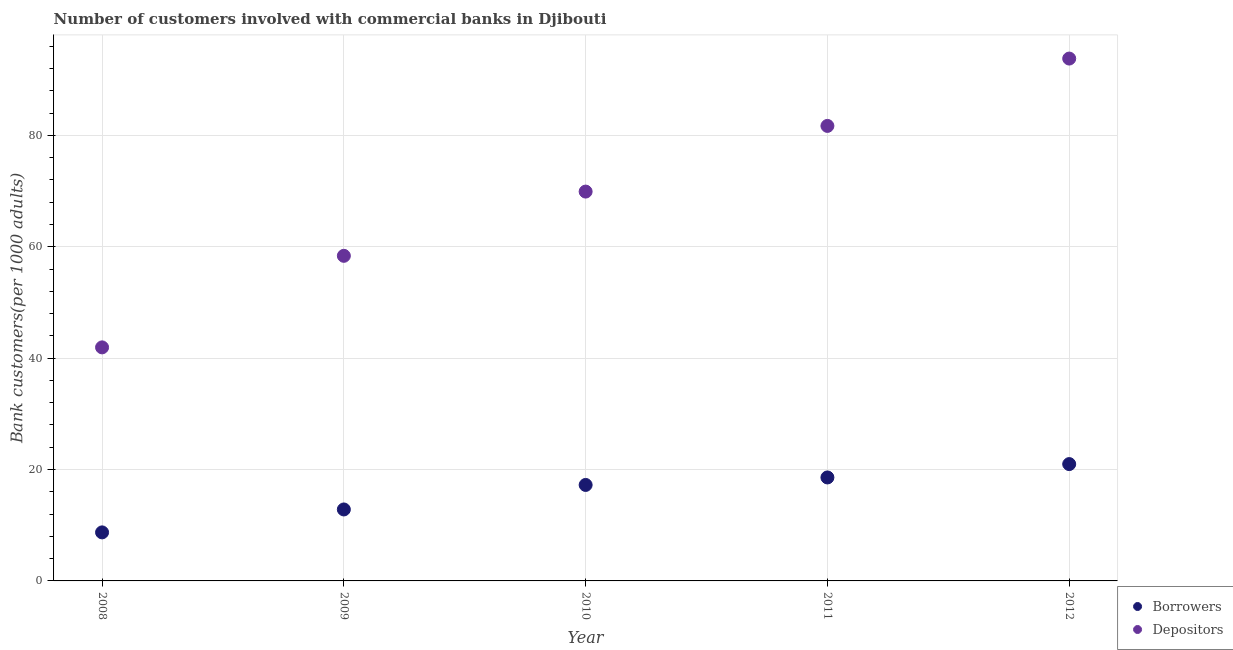How many different coloured dotlines are there?
Make the answer very short. 2. Is the number of dotlines equal to the number of legend labels?
Make the answer very short. Yes. What is the number of borrowers in 2011?
Give a very brief answer. 18.58. Across all years, what is the maximum number of depositors?
Your response must be concise. 93.79. Across all years, what is the minimum number of borrowers?
Provide a short and direct response. 8.72. In which year was the number of borrowers maximum?
Your answer should be very brief. 2012. In which year was the number of depositors minimum?
Ensure brevity in your answer.  2008. What is the total number of borrowers in the graph?
Make the answer very short. 78.34. What is the difference between the number of borrowers in 2009 and that in 2010?
Offer a terse response. -4.4. What is the difference between the number of borrowers in 2011 and the number of depositors in 2008?
Make the answer very short. -23.36. What is the average number of borrowers per year?
Offer a very short reply. 15.67. In the year 2008, what is the difference between the number of depositors and number of borrowers?
Offer a very short reply. 33.22. In how many years, is the number of depositors greater than 28?
Keep it short and to the point. 5. What is the ratio of the number of depositors in 2008 to that in 2009?
Provide a succinct answer. 0.72. Is the number of depositors in 2010 less than that in 2011?
Give a very brief answer. Yes. Is the difference between the number of borrowers in 2010 and 2012 greater than the difference between the number of depositors in 2010 and 2012?
Make the answer very short. Yes. What is the difference between the highest and the second highest number of depositors?
Keep it short and to the point. 12.09. What is the difference between the highest and the lowest number of borrowers?
Give a very brief answer. 12.26. Is the sum of the number of borrowers in 2008 and 2012 greater than the maximum number of depositors across all years?
Make the answer very short. No. Is the number of borrowers strictly greater than the number of depositors over the years?
Your response must be concise. No. How many years are there in the graph?
Keep it short and to the point. 5. Are the values on the major ticks of Y-axis written in scientific E-notation?
Provide a short and direct response. No. What is the title of the graph?
Keep it short and to the point. Number of customers involved with commercial banks in Djibouti. Does "Exports of goods" appear as one of the legend labels in the graph?
Your answer should be very brief. No. What is the label or title of the X-axis?
Ensure brevity in your answer.  Year. What is the label or title of the Y-axis?
Your answer should be compact. Bank customers(per 1000 adults). What is the Bank customers(per 1000 adults) of Borrowers in 2008?
Your answer should be very brief. 8.72. What is the Bank customers(per 1000 adults) in Depositors in 2008?
Provide a succinct answer. 41.94. What is the Bank customers(per 1000 adults) of Borrowers in 2009?
Offer a terse response. 12.83. What is the Bank customers(per 1000 adults) of Depositors in 2009?
Your response must be concise. 58.37. What is the Bank customers(per 1000 adults) in Borrowers in 2010?
Your response must be concise. 17.23. What is the Bank customers(per 1000 adults) of Depositors in 2010?
Your answer should be very brief. 69.91. What is the Bank customers(per 1000 adults) of Borrowers in 2011?
Give a very brief answer. 18.58. What is the Bank customers(per 1000 adults) of Depositors in 2011?
Your answer should be very brief. 81.7. What is the Bank customers(per 1000 adults) of Borrowers in 2012?
Provide a short and direct response. 20.98. What is the Bank customers(per 1000 adults) in Depositors in 2012?
Offer a very short reply. 93.79. Across all years, what is the maximum Bank customers(per 1000 adults) in Borrowers?
Keep it short and to the point. 20.98. Across all years, what is the maximum Bank customers(per 1000 adults) in Depositors?
Give a very brief answer. 93.79. Across all years, what is the minimum Bank customers(per 1000 adults) of Borrowers?
Provide a short and direct response. 8.72. Across all years, what is the minimum Bank customers(per 1000 adults) in Depositors?
Provide a short and direct response. 41.94. What is the total Bank customers(per 1000 adults) in Borrowers in the graph?
Provide a short and direct response. 78.34. What is the total Bank customers(per 1000 adults) of Depositors in the graph?
Make the answer very short. 345.72. What is the difference between the Bank customers(per 1000 adults) in Borrowers in 2008 and that in 2009?
Your answer should be very brief. -4.12. What is the difference between the Bank customers(per 1000 adults) of Depositors in 2008 and that in 2009?
Keep it short and to the point. -16.44. What is the difference between the Bank customers(per 1000 adults) of Borrowers in 2008 and that in 2010?
Offer a terse response. -8.52. What is the difference between the Bank customers(per 1000 adults) of Depositors in 2008 and that in 2010?
Your response must be concise. -27.97. What is the difference between the Bank customers(per 1000 adults) of Borrowers in 2008 and that in 2011?
Give a very brief answer. -9.86. What is the difference between the Bank customers(per 1000 adults) in Depositors in 2008 and that in 2011?
Your answer should be compact. -39.77. What is the difference between the Bank customers(per 1000 adults) in Borrowers in 2008 and that in 2012?
Provide a succinct answer. -12.26. What is the difference between the Bank customers(per 1000 adults) in Depositors in 2008 and that in 2012?
Ensure brevity in your answer.  -51.86. What is the difference between the Bank customers(per 1000 adults) of Borrowers in 2009 and that in 2010?
Your answer should be very brief. -4.4. What is the difference between the Bank customers(per 1000 adults) in Depositors in 2009 and that in 2010?
Your response must be concise. -11.54. What is the difference between the Bank customers(per 1000 adults) in Borrowers in 2009 and that in 2011?
Your answer should be very brief. -5.75. What is the difference between the Bank customers(per 1000 adults) in Depositors in 2009 and that in 2011?
Provide a succinct answer. -23.33. What is the difference between the Bank customers(per 1000 adults) in Borrowers in 2009 and that in 2012?
Provide a succinct answer. -8.15. What is the difference between the Bank customers(per 1000 adults) of Depositors in 2009 and that in 2012?
Your response must be concise. -35.42. What is the difference between the Bank customers(per 1000 adults) in Borrowers in 2010 and that in 2011?
Keep it short and to the point. -1.35. What is the difference between the Bank customers(per 1000 adults) in Depositors in 2010 and that in 2011?
Make the answer very short. -11.79. What is the difference between the Bank customers(per 1000 adults) of Borrowers in 2010 and that in 2012?
Ensure brevity in your answer.  -3.75. What is the difference between the Bank customers(per 1000 adults) of Depositors in 2010 and that in 2012?
Make the answer very short. -23.88. What is the difference between the Bank customers(per 1000 adults) of Borrowers in 2011 and that in 2012?
Offer a terse response. -2.4. What is the difference between the Bank customers(per 1000 adults) in Depositors in 2011 and that in 2012?
Offer a very short reply. -12.09. What is the difference between the Bank customers(per 1000 adults) in Borrowers in 2008 and the Bank customers(per 1000 adults) in Depositors in 2009?
Give a very brief answer. -49.66. What is the difference between the Bank customers(per 1000 adults) of Borrowers in 2008 and the Bank customers(per 1000 adults) of Depositors in 2010?
Provide a short and direct response. -61.19. What is the difference between the Bank customers(per 1000 adults) in Borrowers in 2008 and the Bank customers(per 1000 adults) in Depositors in 2011?
Keep it short and to the point. -72.99. What is the difference between the Bank customers(per 1000 adults) in Borrowers in 2008 and the Bank customers(per 1000 adults) in Depositors in 2012?
Your response must be concise. -85.08. What is the difference between the Bank customers(per 1000 adults) of Borrowers in 2009 and the Bank customers(per 1000 adults) of Depositors in 2010?
Offer a terse response. -57.08. What is the difference between the Bank customers(per 1000 adults) in Borrowers in 2009 and the Bank customers(per 1000 adults) in Depositors in 2011?
Provide a succinct answer. -68.87. What is the difference between the Bank customers(per 1000 adults) of Borrowers in 2009 and the Bank customers(per 1000 adults) of Depositors in 2012?
Ensure brevity in your answer.  -80.96. What is the difference between the Bank customers(per 1000 adults) in Borrowers in 2010 and the Bank customers(per 1000 adults) in Depositors in 2011?
Give a very brief answer. -64.47. What is the difference between the Bank customers(per 1000 adults) of Borrowers in 2010 and the Bank customers(per 1000 adults) of Depositors in 2012?
Offer a terse response. -76.56. What is the difference between the Bank customers(per 1000 adults) of Borrowers in 2011 and the Bank customers(per 1000 adults) of Depositors in 2012?
Give a very brief answer. -75.22. What is the average Bank customers(per 1000 adults) in Borrowers per year?
Keep it short and to the point. 15.67. What is the average Bank customers(per 1000 adults) in Depositors per year?
Offer a very short reply. 69.14. In the year 2008, what is the difference between the Bank customers(per 1000 adults) of Borrowers and Bank customers(per 1000 adults) of Depositors?
Provide a succinct answer. -33.22. In the year 2009, what is the difference between the Bank customers(per 1000 adults) of Borrowers and Bank customers(per 1000 adults) of Depositors?
Offer a terse response. -45.54. In the year 2010, what is the difference between the Bank customers(per 1000 adults) in Borrowers and Bank customers(per 1000 adults) in Depositors?
Your answer should be very brief. -52.68. In the year 2011, what is the difference between the Bank customers(per 1000 adults) in Borrowers and Bank customers(per 1000 adults) in Depositors?
Ensure brevity in your answer.  -63.12. In the year 2012, what is the difference between the Bank customers(per 1000 adults) of Borrowers and Bank customers(per 1000 adults) of Depositors?
Make the answer very short. -72.82. What is the ratio of the Bank customers(per 1000 adults) in Borrowers in 2008 to that in 2009?
Provide a succinct answer. 0.68. What is the ratio of the Bank customers(per 1000 adults) of Depositors in 2008 to that in 2009?
Offer a terse response. 0.72. What is the ratio of the Bank customers(per 1000 adults) in Borrowers in 2008 to that in 2010?
Ensure brevity in your answer.  0.51. What is the ratio of the Bank customers(per 1000 adults) in Depositors in 2008 to that in 2010?
Your response must be concise. 0.6. What is the ratio of the Bank customers(per 1000 adults) in Borrowers in 2008 to that in 2011?
Make the answer very short. 0.47. What is the ratio of the Bank customers(per 1000 adults) in Depositors in 2008 to that in 2011?
Make the answer very short. 0.51. What is the ratio of the Bank customers(per 1000 adults) in Borrowers in 2008 to that in 2012?
Offer a very short reply. 0.42. What is the ratio of the Bank customers(per 1000 adults) of Depositors in 2008 to that in 2012?
Ensure brevity in your answer.  0.45. What is the ratio of the Bank customers(per 1000 adults) in Borrowers in 2009 to that in 2010?
Your answer should be compact. 0.74. What is the ratio of the Bank customers(per 1000 adults) of Depositors in 2009 to that in 2010?
Provide a short and direct response. 0.83. What is the ratio of the Bank customers(per 1000 adults) of Borrowers in 2009 to that in 2011?
Ensure brevity in your answer.  0.69. What is the ratio of the Bank customers(per 1000 adults) in Depositors in 2009 to that in 2011?
Your response must be concise. 0.71. What is the ratio of the Bank customers(per 1000 adults) in Borrowers in 2009 to that in 2012?
Provide a short and direct response. 0.61. What is the ratio of the Bank customers(per 1000 adults) of Depositors in 2009 to that in 2012?
Provide a short and direct response. 0.62. What is the ratio of the Bank customers(per 1000 adults) of Borrowers in 2010 to that in 2011?
Provide a short and direct response. 0.93. What is the ratio of the Bank customers(per 1000 adults) in Depositors in 2010 to that in 2011?
Give a very brief answer. 0.86. What is the ratio of the Bank customers(per 1000 adults) of Borrowers in 2010 to that in 2012?
Keep it short and to the point. 0.82. What is the ratio of the Bank customers(per 1000 adults) in Depositors in 2010 to that in 2012?
Your response must be concise. 0.75. What is the ratio of the Bank customers(per 1000 adults) in Borrowers in 2011 to that in 2012?
Make the answer very short. 0.89. What is the ratio of the Bank customers(per 1000 adults) of Depositors in 2011 to that in 2012?
Provide a succinct answer. 0.87. What is the difference between the highest and the second highest Bank customers(per 1000 adults) of Borrowers?
Provide a succinct answer. 2.4. What is the difference between the highest and the second highest Bank customers(per 1000 adults) in Depositors?
Offer a very short reply. 12.09. What is the difference between the highest and the lowest Bank customers(per 1000 adults) in Borrowers?
Keep it short and to the point. 12.26. What is the difference between the highest and the lowest Bank customers(per 1000 adults) of Depositors?
Provide a short and direct response. 51.86. 